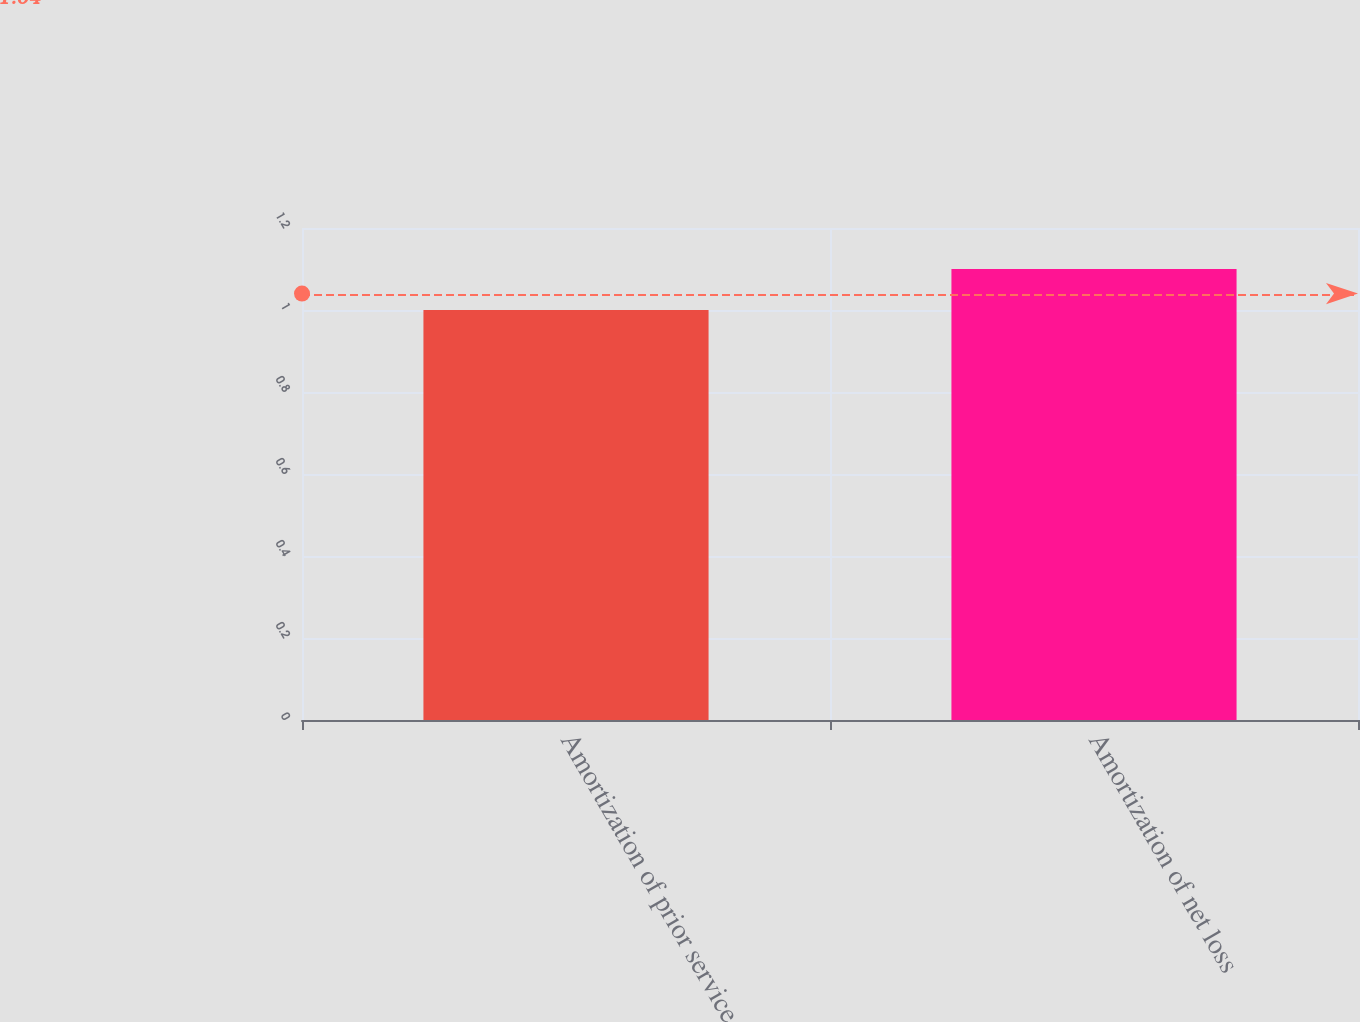<chart> <loc_0><loc_0><loc_500><loc_500><bar_chart><fcel>Amortization of prior service<fcel>Amortization of net loss<nl><fcel>1<fcel>1.1<nl></chart> 